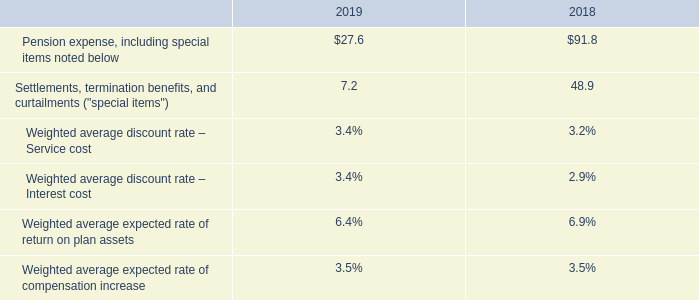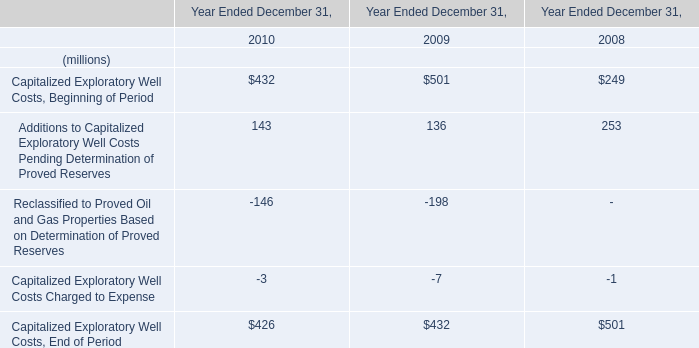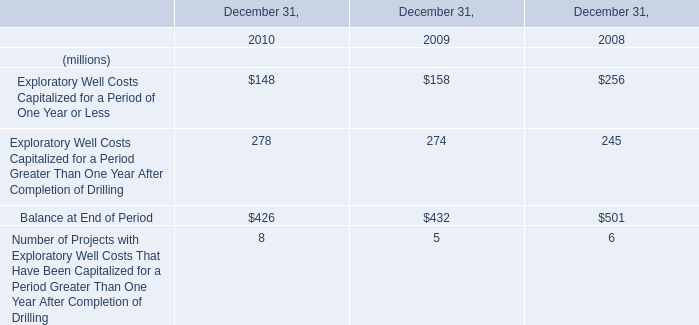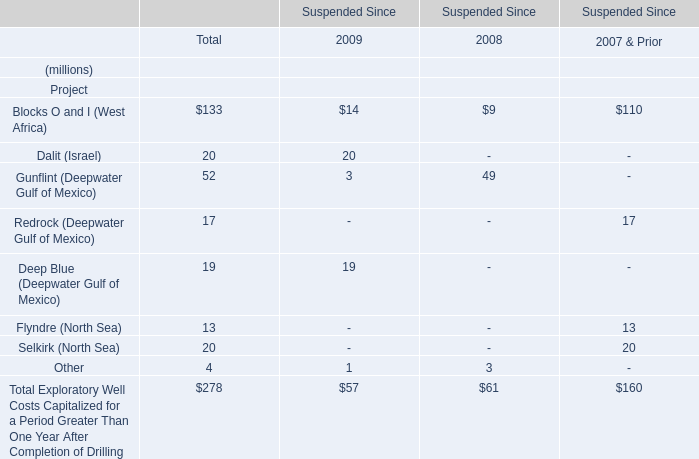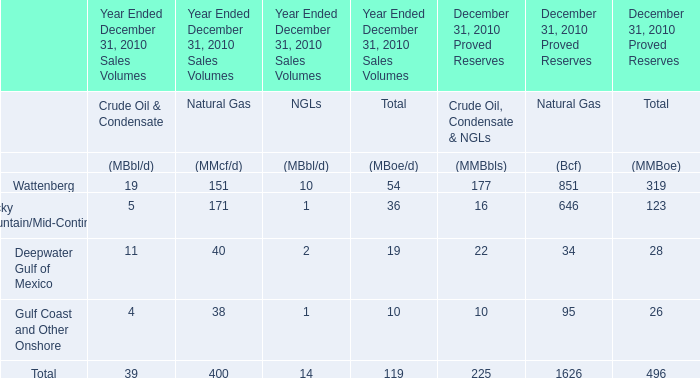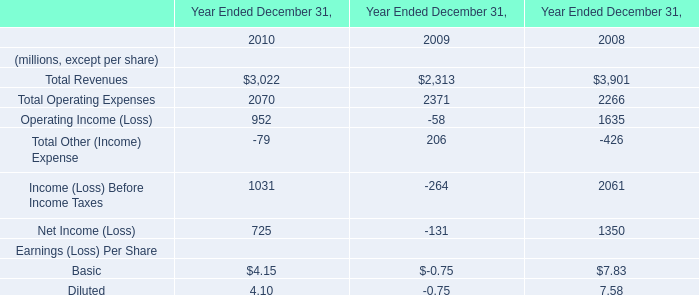Which year is Capitalized Exploratory Well Costs, Beginning of Period greater than 500 ? 
Answer: 2009. 